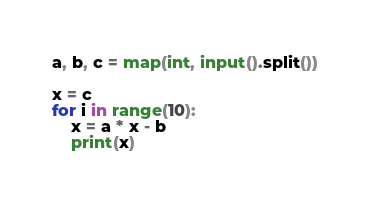Convert code to text. <code><loc_0><loc_0><loc_500><loc_500><_Python_>a, b, c = map(int, input().split())

x = c
for i in range(10):
    x = a * x - b
    print(x)
</code> 